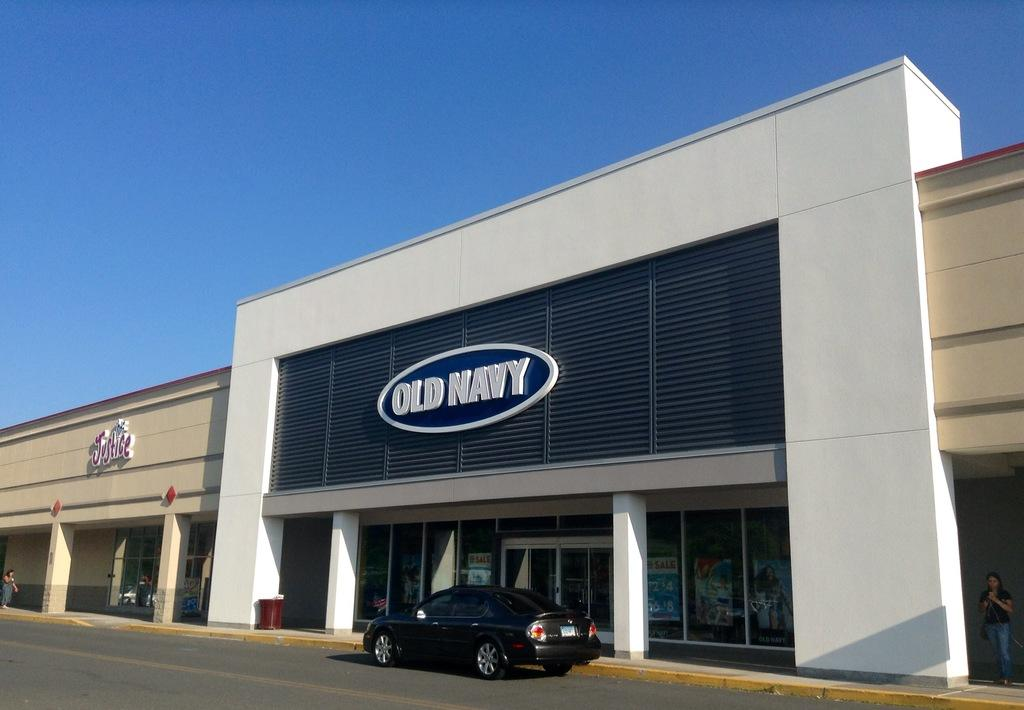What type of structure is visible in the image? There is a building in the image. What architectural features can be seen on the building? There are pillars in the image. What are the boards used for in the image? Something is written on the boards, which suggests they might be used for communication or displaying information. Who is present in the image? There are people in the image. What is the purpose of the card in the image? It is not clear from the facts what the card is used for, but it is present in the image. What is the purpose of the bin in the image? The bin might be used for waste disposal or storage. What can be seen in the sky in the image? The sky is visible in the image. What other objects are present in the image? There are objects in the image, but their specific nature is not mentioned in the facts. What type of suit is the person wearing in the image? There is no mention of a suit or any clothing in the image. How does the bridge connect to the building in the image? There is no bridge present in the image. 